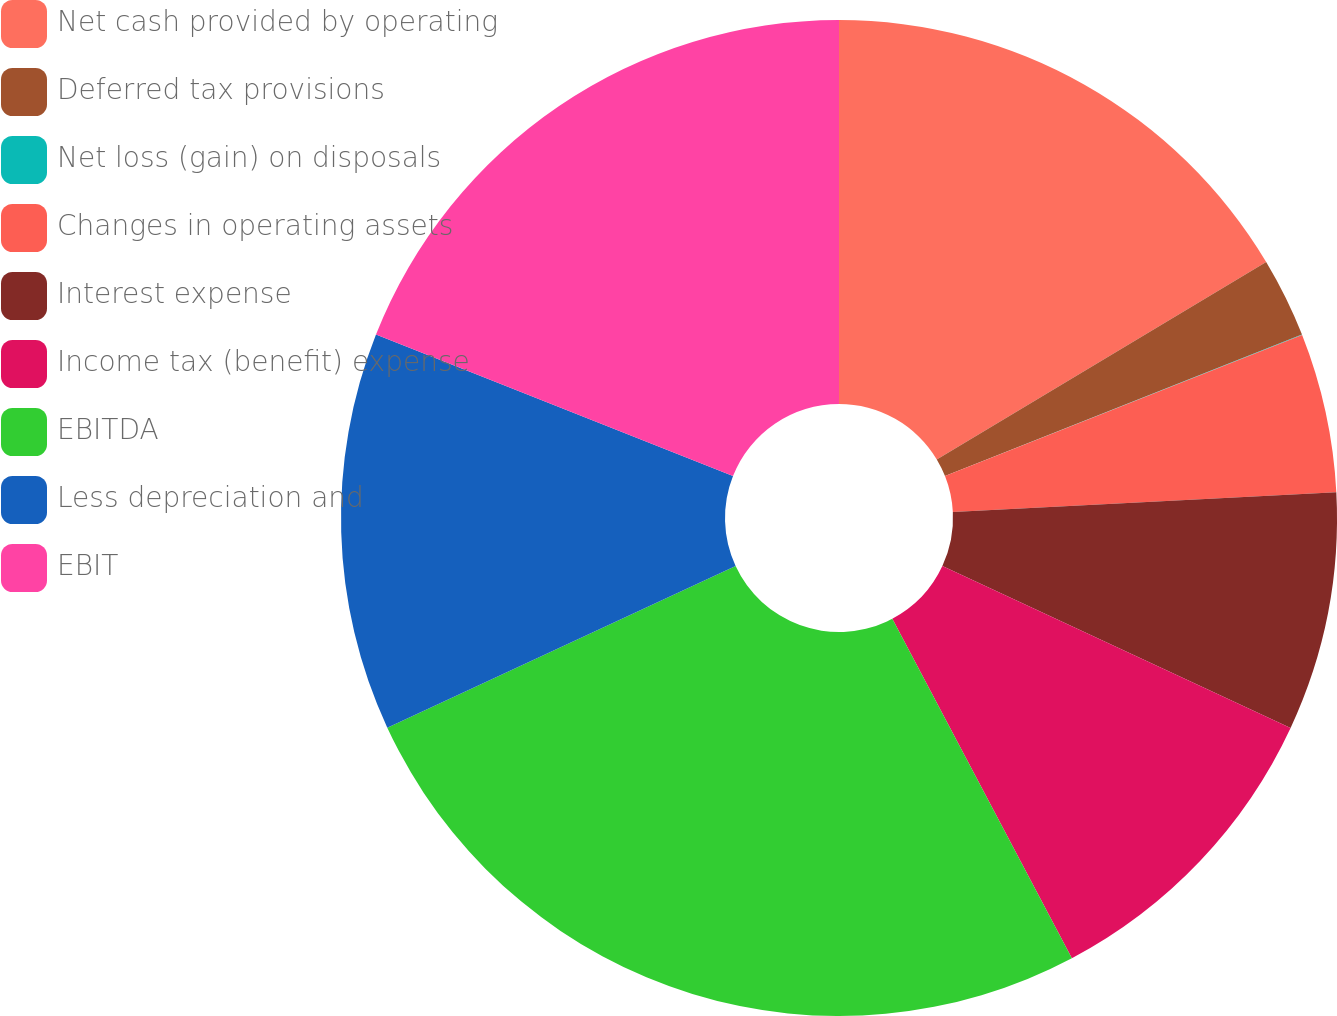Convert chart. <chart><loc_0><loc_0><loc_500><loc_500><pie_chart><fcel>Net cash provided by operating<fcel>Deferred tax provisions<fcel>Net loss (gain) on disposals<fcel>Changes in operating assets<fcel>Interest expense<fcel>Income tax (benefit) expense<fcel>EBITDA<fcel>Less depreciation and<fcel>EBIT<nl><fcel>16.41%<fcel>2.59%<fcel>0.01%<fcel>5.17%<fcel>7.75%<fcel>10.33%<fcel>25.83%<fcel>12.92%<fcel>19.0%<nl></chart> 